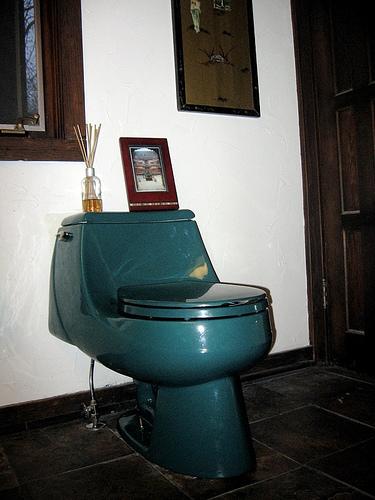Why is this a piece of art?
Keep it brief. Color. What color is the toilet?
Short answer required. Blue. Is it important to keep this object clean?
Answer briefly. Yes. What surface does the appliance sit atop?
Be succinct. Tile. What type of material is the floor?
Answer briefly. Tile. 